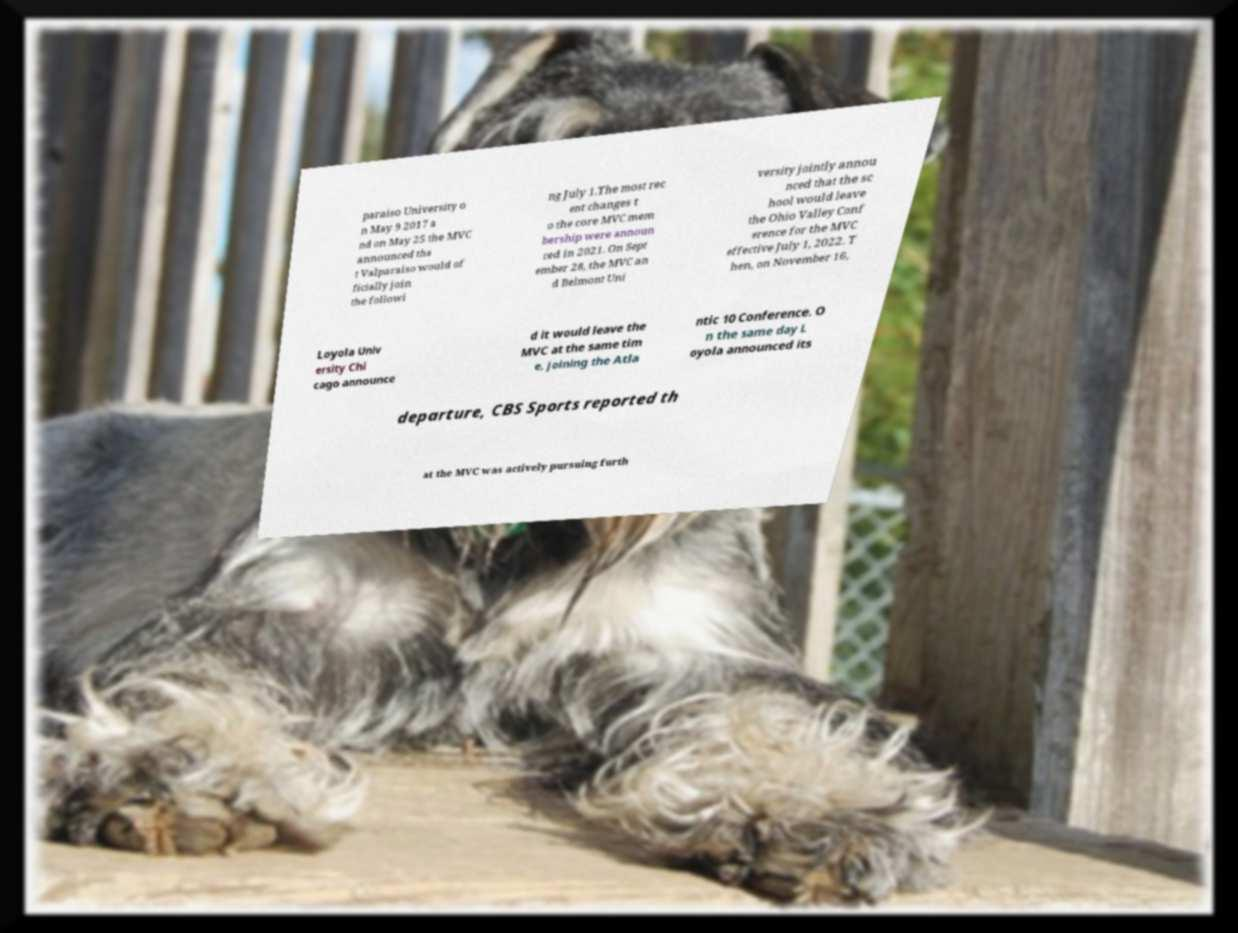What messages or text are displayed in this image? I need them in a readable, typed format. paraiso University o n May 9 2017 a nd on May 25 the MVC announced tha t Valparaiso would of ficially join the followi ng July 1.The most rec ent changes t o the core MVC mem bership were announ ced in 2021. On Sept ember 28, the MVC an d Belmont Uni versity jointly annou nced that the sc hool would leave the Ohio Valley Conf erence for the MVC effective July 1, 2022. T hen, on November 16, Loyola Univ ersity Chi cago announce d it would leave the MVC at the same tim e, joining the Atla ntic 10 Conference. O n the same day L oyola announced its departure, CBS Sports reported th at the MVC was actively pursuing furth 